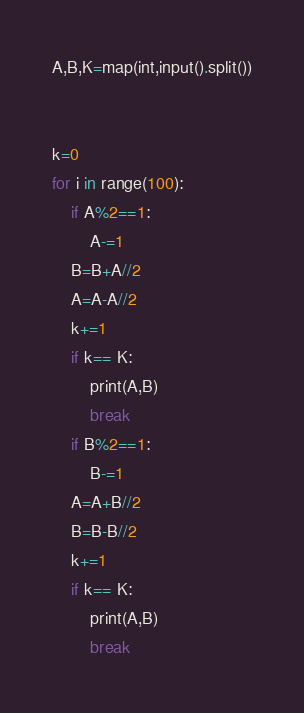<code> <loc_0><loc_0><loc_500><loc_500><_Python_>A,B,K=map(int,input().split())


k=0
for i in range(100):
    if A%2==1:
        A-=1
    B=B+A//2
    A=A-A//2
    k+=1
    if k== K:
        print(A,B)
        break
    if B%2==1:
        B-=1
    A=A+B//2
    B=B-B//2
    k+=1
    if k== K:
        print(A,B)
        break</code> 